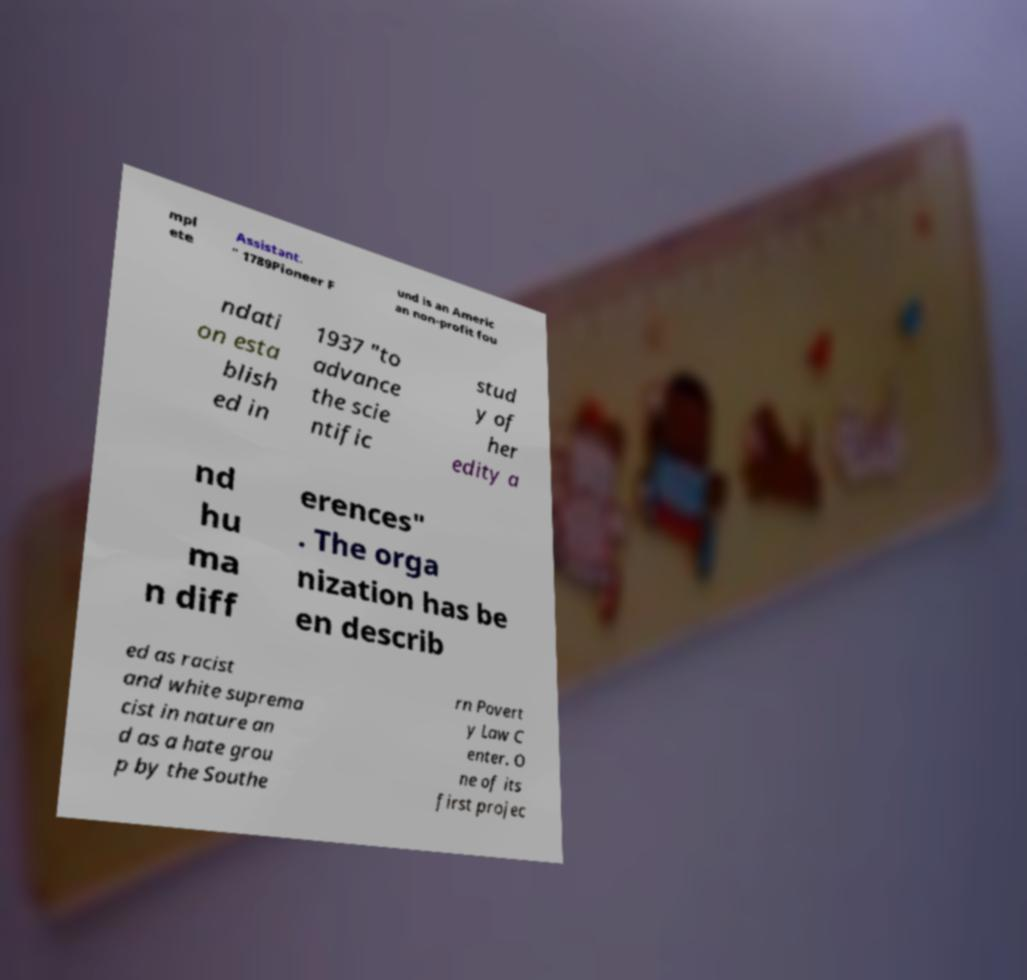Can you accurately transcribe the text from the provided image for me? mpl ete Assistant. " 1789Pioneer F und is an Americ an non-profit fou ndati on esta blish ed in 1937 "to advance the scie ntific stud y of her edity a nd hu ma n diff erences" . The orga nization has be en describ ed as racist and white suprema cist in nature an d as a hate grou p by the Southe rn Povert y Law C enter. O ne of its first projec 